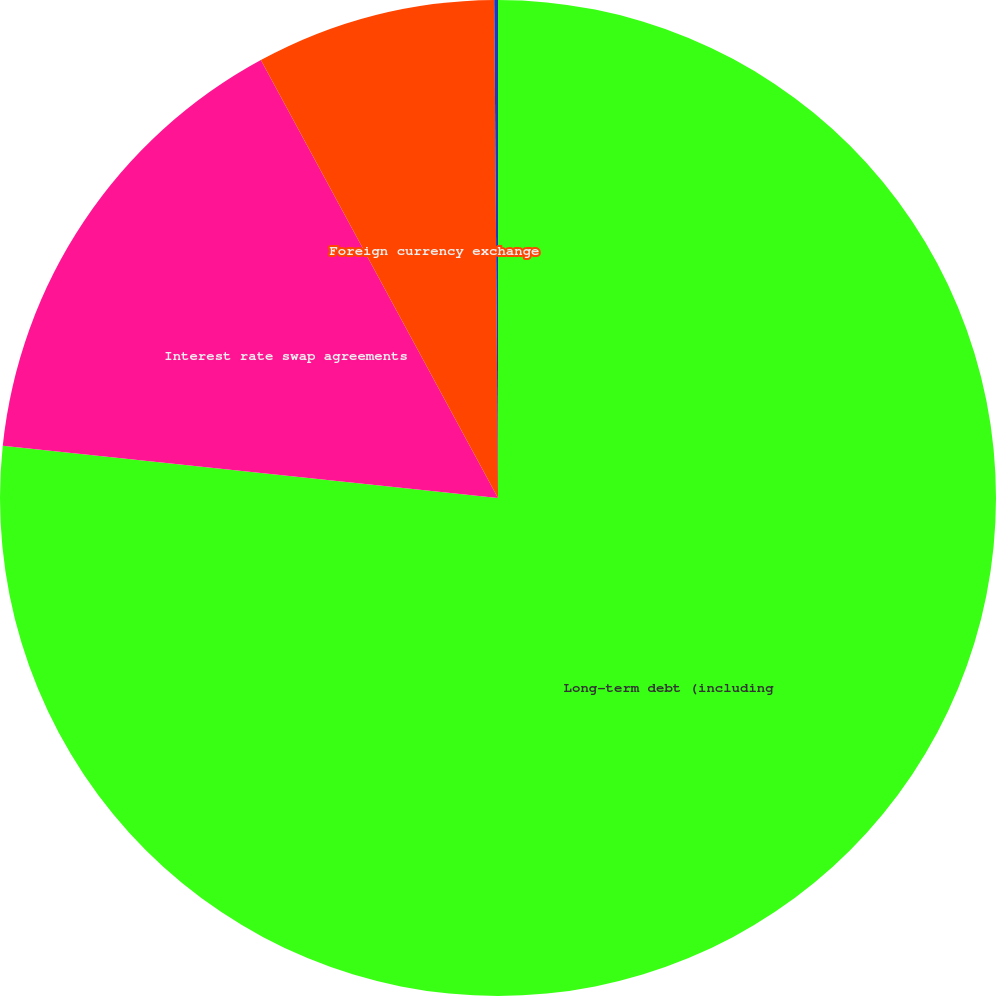<chart> <loc_0><loc_0><loc_500><loc_500><pie_chart><fcel>Long-term debt (including<fcel>Interest rate swap agreements<fcel>Foreign currency exchange<fcel>Forward commodity contracts(3)<nl><fcel>76.67%<fcel>15.43%<fcel>7.78%<fcel>0.12%<nl></chart> 